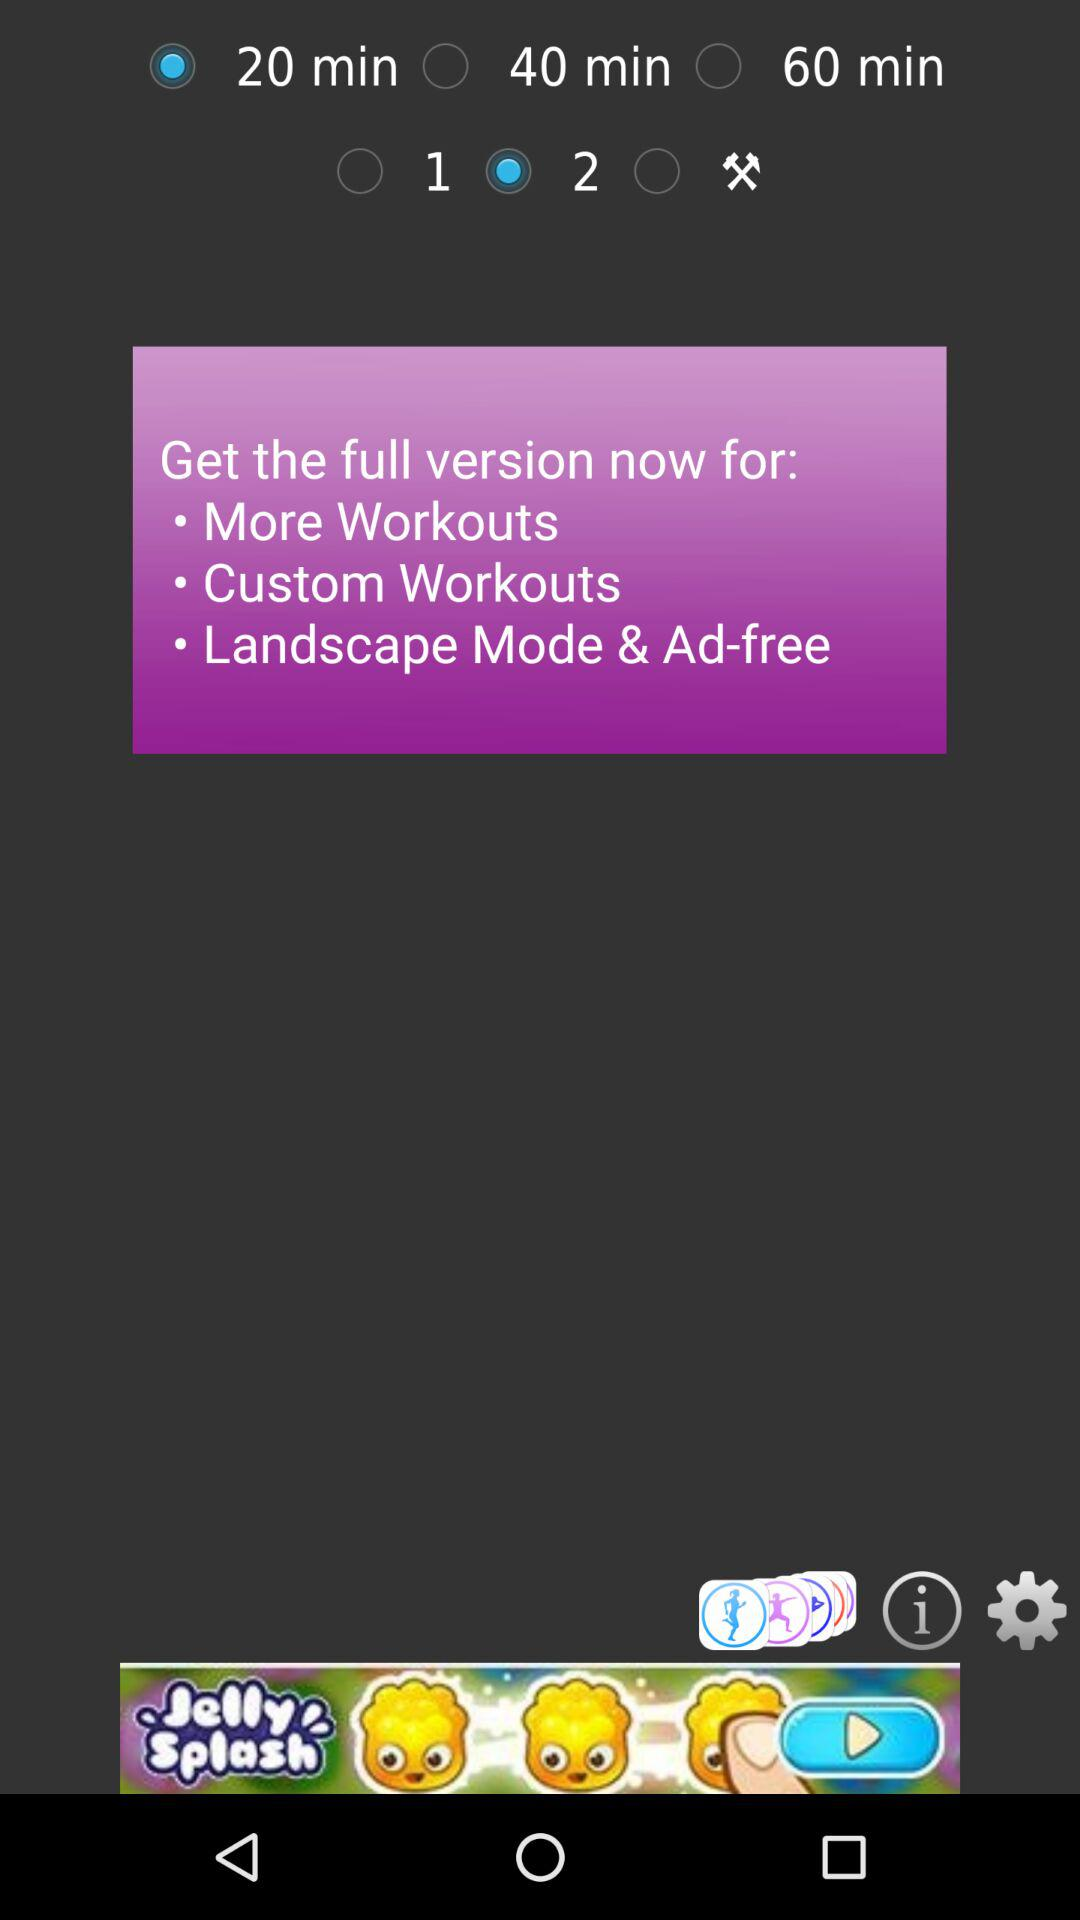Which radio button is selected? The selected radio buttons are "20 min" and "2". 